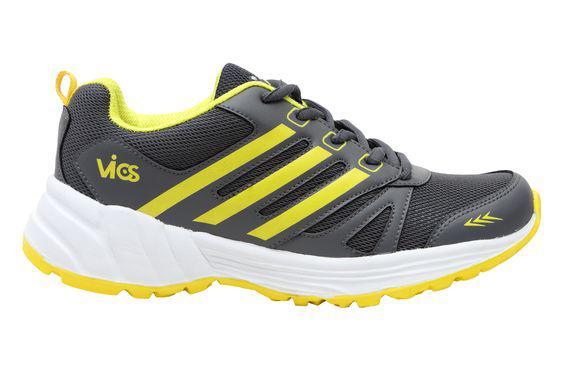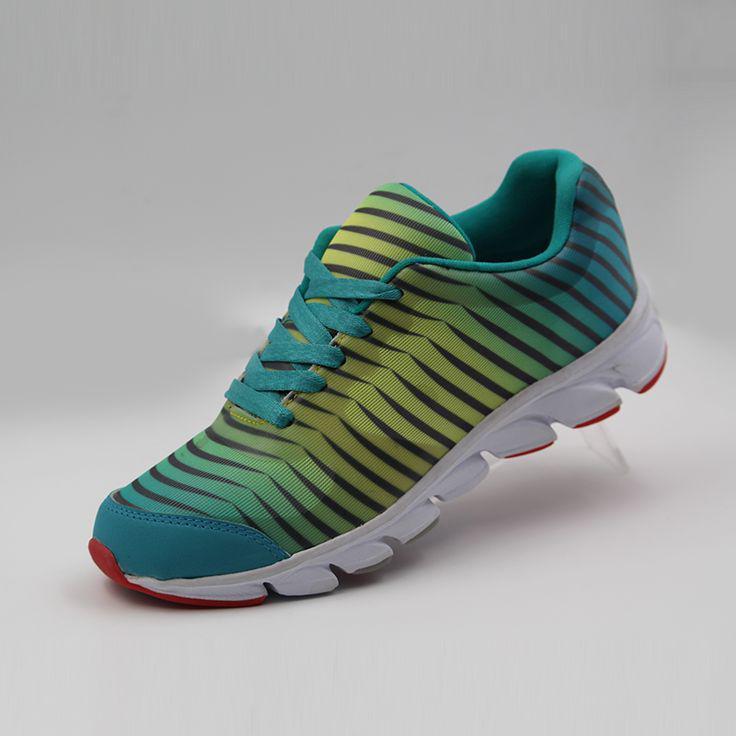The first image is the image on the left, the second image is the image on the right. For the images displayed, is the sentence "The toe of the shoe in the image on the right is pointed to the left." factually correct? Answer yes or no. Yes. The first image is the image on the left, the second image is the image on the right. Analyze the images presented: Is the assertion "Right image contains one shoe tilted and facing rightward, with a cat silhouette somewhere on it." valid? Answer yes or no. No. 